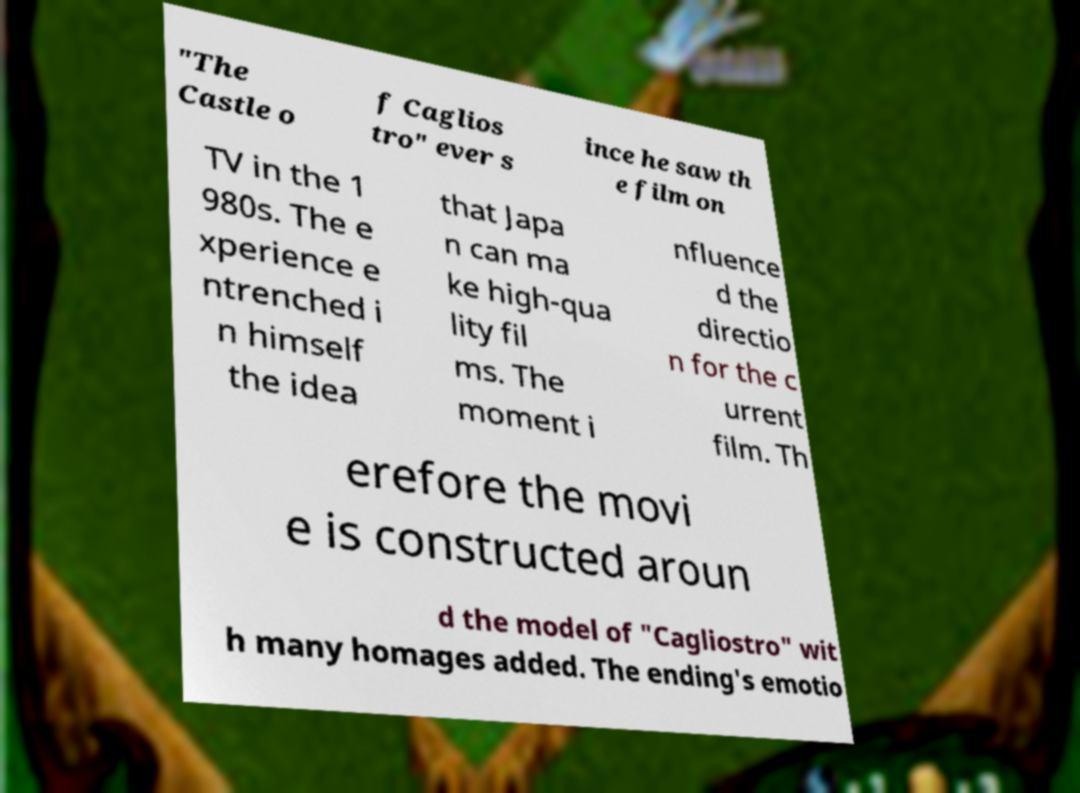I need the written content from this picture converted into text. Can you do that? "The Castle o f Caglios tro" ever s ince he saw th e film on TV in the 1 980s. The e xperience e ntrenched i n himself the idea that Japa n can ma ke high-qua lity fil ms. The moment i nfluence d the directio n for the c urrent film. Th erefore the movi e is constructed aroun d the model of "Cagliostro" wit h many homages added. The ending's emotio 